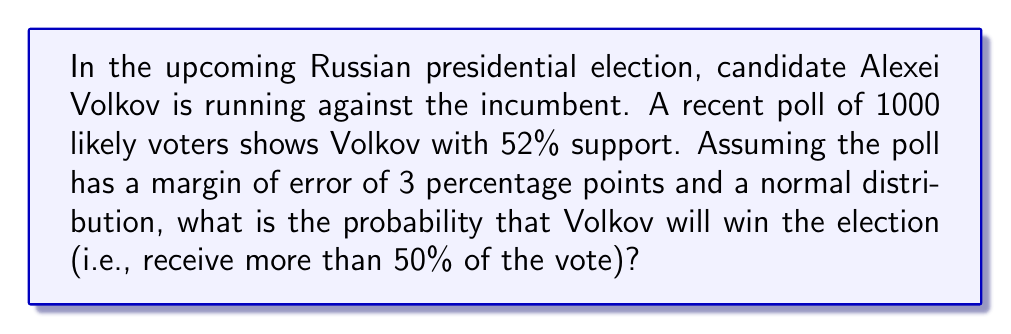Can you answer this question? To solve this problem, we need to use the properties of the normal distribution and calculate the z-score.

1. First, we identify the key information:
   - Sample size (n) = 1000
   - Observed proportion (p) = 52% = 0.52
   - Margin of error = 3 percentage points = 0.03
   - Threshold for winning = 50% = 0.5

2. Calculate the standard error (SE) of the proportion:
   $$ SE = \sqrt{\frac{p(1-p)}{n}} = \sqrt{\frac{0.52(1-0.52)}{1000}} \approx 0.0158 $$

3. The margin of error (ME) is related to the standard error by:
   $$ ME = z \cdot SE $$
   where z is the z-score for the desired confidence level. We can find z:
   $$ z = \frac{ME}{SE} = \frac{0.03}{0.0158} \approx 1.90 $$
   This corresponds to approximately a 94% confidence level.

4. To find the probability of Volkov winning, we need to calculate the z-score for the threshold of 50%:
   $$ z = \frac{0.50 - 0.52}{0.0158} \approx -1.27 $$

5. The probability of Volkov winning is the area to the right of z = -1.27 on the standard normal distribution. We can find this using a z-table or a calculator:
   $$ P(Z > -1.27) \approx 0.8980 $$

Therefore, based on this polling data, there is approximately an 89.80% chance that Volkov will win the election.
Answer: The probability that Alexei Volkov will win the election is approximately 0.8980 or 89.80%. 